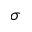<formula> <loc_0><loc_0><loc_500><loc_500>\sigma</formula> 